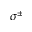Convert formula to latex. <formula><loc_0><loc_0><loc_500><loc_500>\sigma ^ { \pm }</formula> 